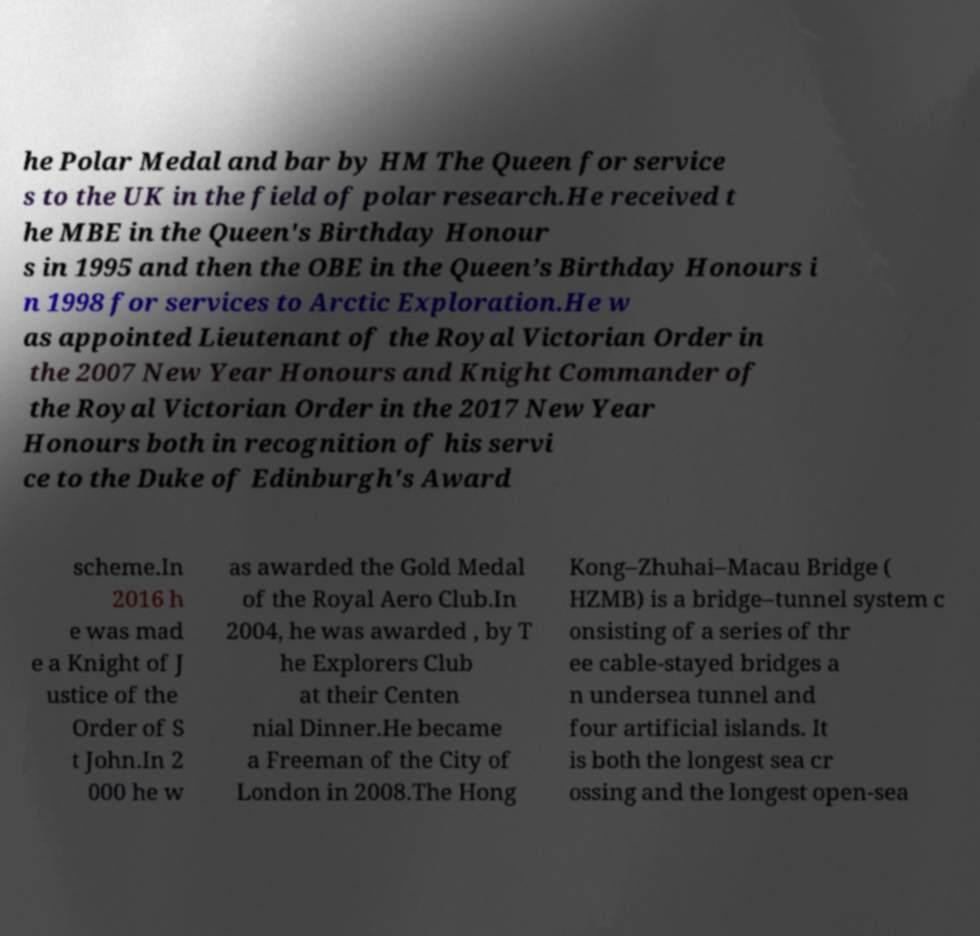Please identify and transcribe the text found in this image. he Polar Medal and bar by HM The Queen for service s to the UK in the field of polar research.He received t he MBE in the Queen's Birthday Honour s in 1995 and then the OBE in the Queen’s Birthday Honours i n 1998 for services to Arctic Exploration.He w as appointed Lieutenant of the Royal Victorian Order in the 2007 New Year Honours and Knight Commander of the Royal Victorian Order in the 2017 New Year Honours both in recognition of his servi ce to the Duke of Edinburgh's Award scheme.In 2016 h e was mad e a Knight of J ustice of the Order of S t John.In 2 000 he w as awarded the Gold Medal of the Royal Aero Club.In 2004, he was awarded , by T he Explorers Club at their Centen nial Dinner.He became a Freeman of the City of London in 2008.The Hong Kong–Zhuhai–Macau Bridge ( HZMB) is a bridge–tunnel system c onsisting of a series of thr ee cable-stayed bridges a n undersea tunnel and four artificial islands. It is both the longest sea cr ossing and the longest open-sea 